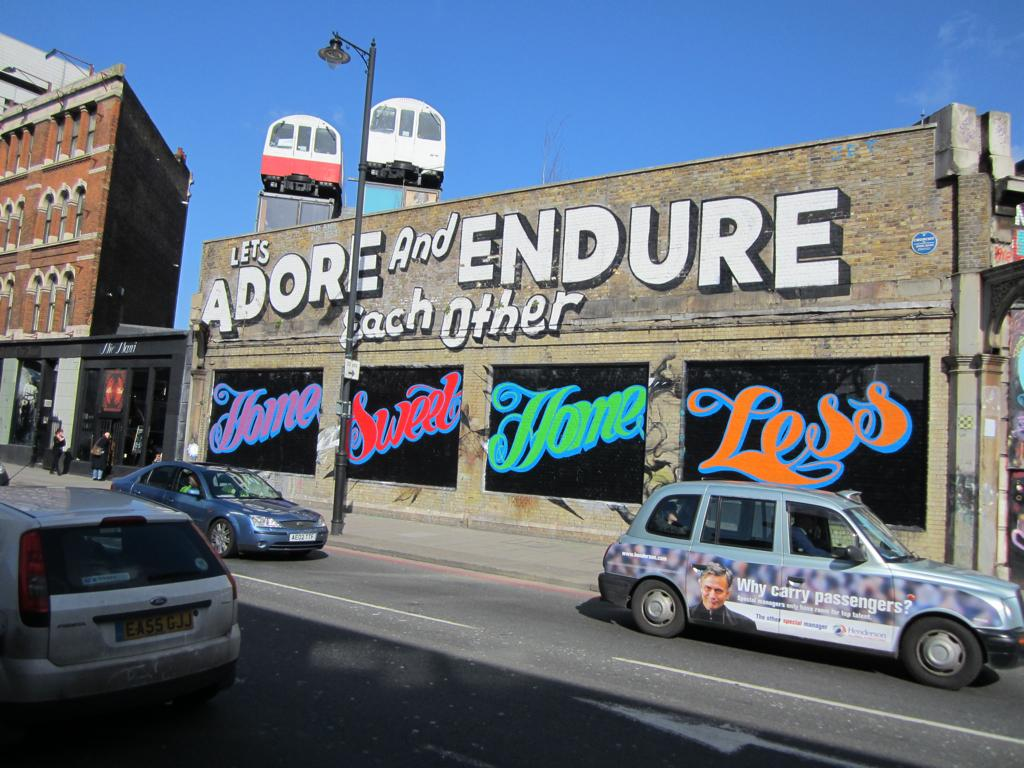<image>
Render a clear and concise summary of the photo. the word endure is on the front of a building 